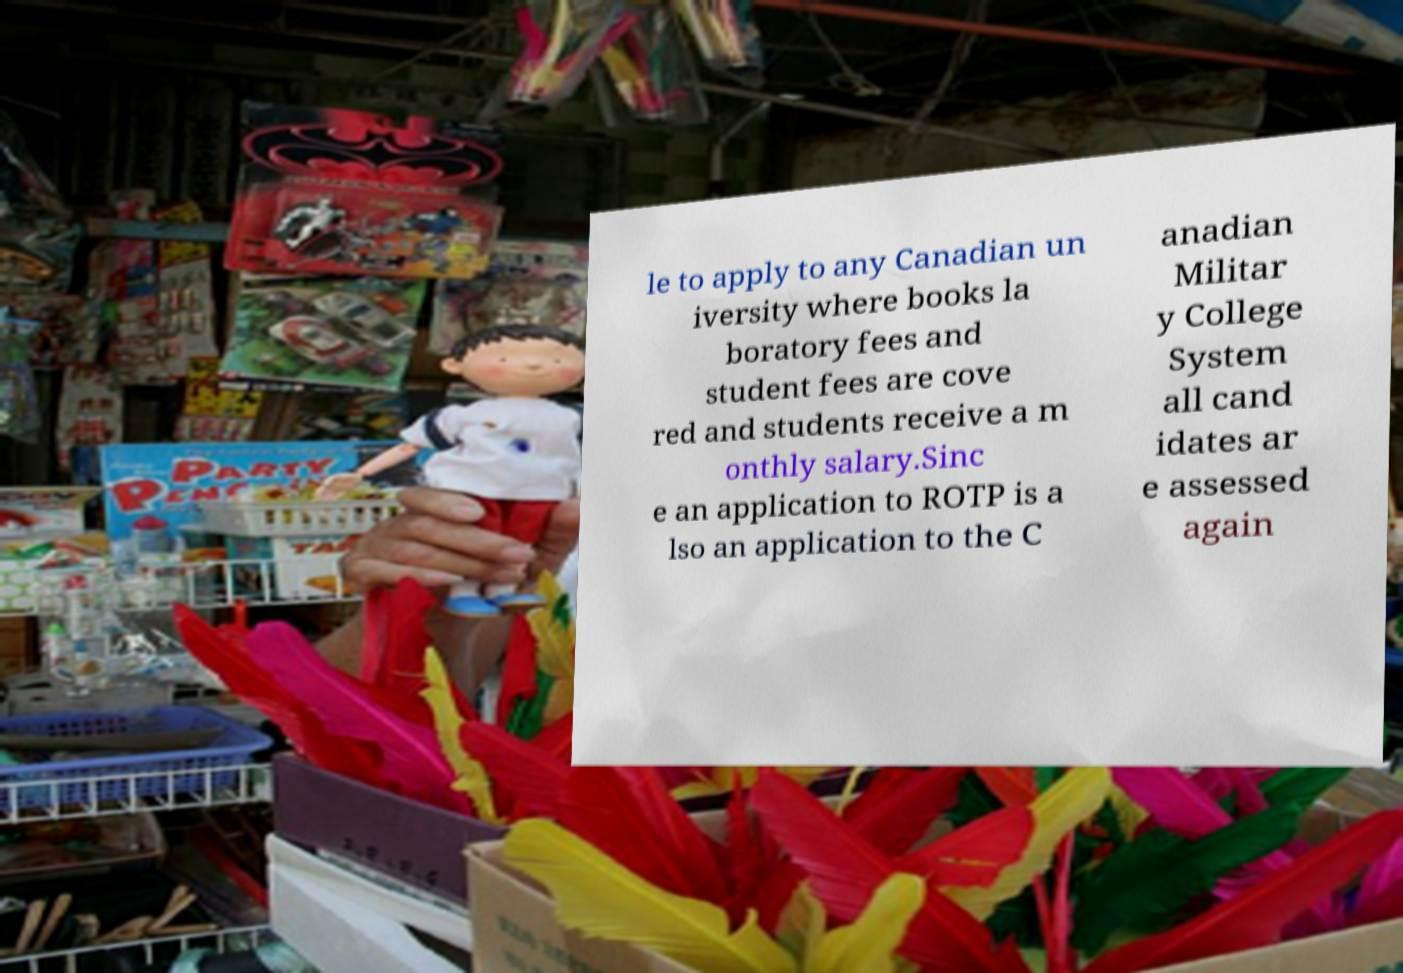For documentation purposes, I need the text within this image transcribed. Could you provide that? le to apply to any Canadian un iversity where books la boratory fees and student fees are cove red and students receive a m onthly salary.Sinc e an application to ROTP is a lso an application to the C anadian Militar y College System all cand idates ar e assessed again 